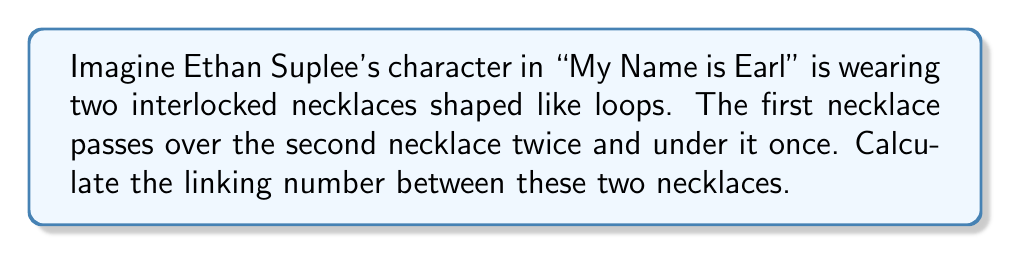Teach me how to tackle this problem. To calculate the linking number between two interlocked loops, we follow these steps:

1. Assign an orientation to each loop. Let's assume both necklaces are oriented clockwise when viewed from above.

2. Count the number of crossings where one loop passes over the other:
   - Positive crossings: When the upper strand's orientation aligns with the direction from the lower strand to the upper strand.
   - Negative crossings: When the upper strand's orientation opposes the direction from the lower strand to the upper strand.

3. In this case:
   - We have 2 positive crossings (over)
   - We have 1 negative crossing (under)

4. Calculate the linking number using the formula:

   $$\text{Linking Number} = \frac{1}{2}(\text{Positive Crossings} - \text{Negative Crossings})$$

5. Substituting our values:

   $$\text{Linking Number} = \frac{1}{2}(2 - 1) = \frac{1}{2}(1) = \frac{1}{2}$$

Therefore, the linking number between Ethan Suplee's character's two interlocked necklaces is $\frac{1}{2}$.
Answer: $\frac{1}{2}$ 